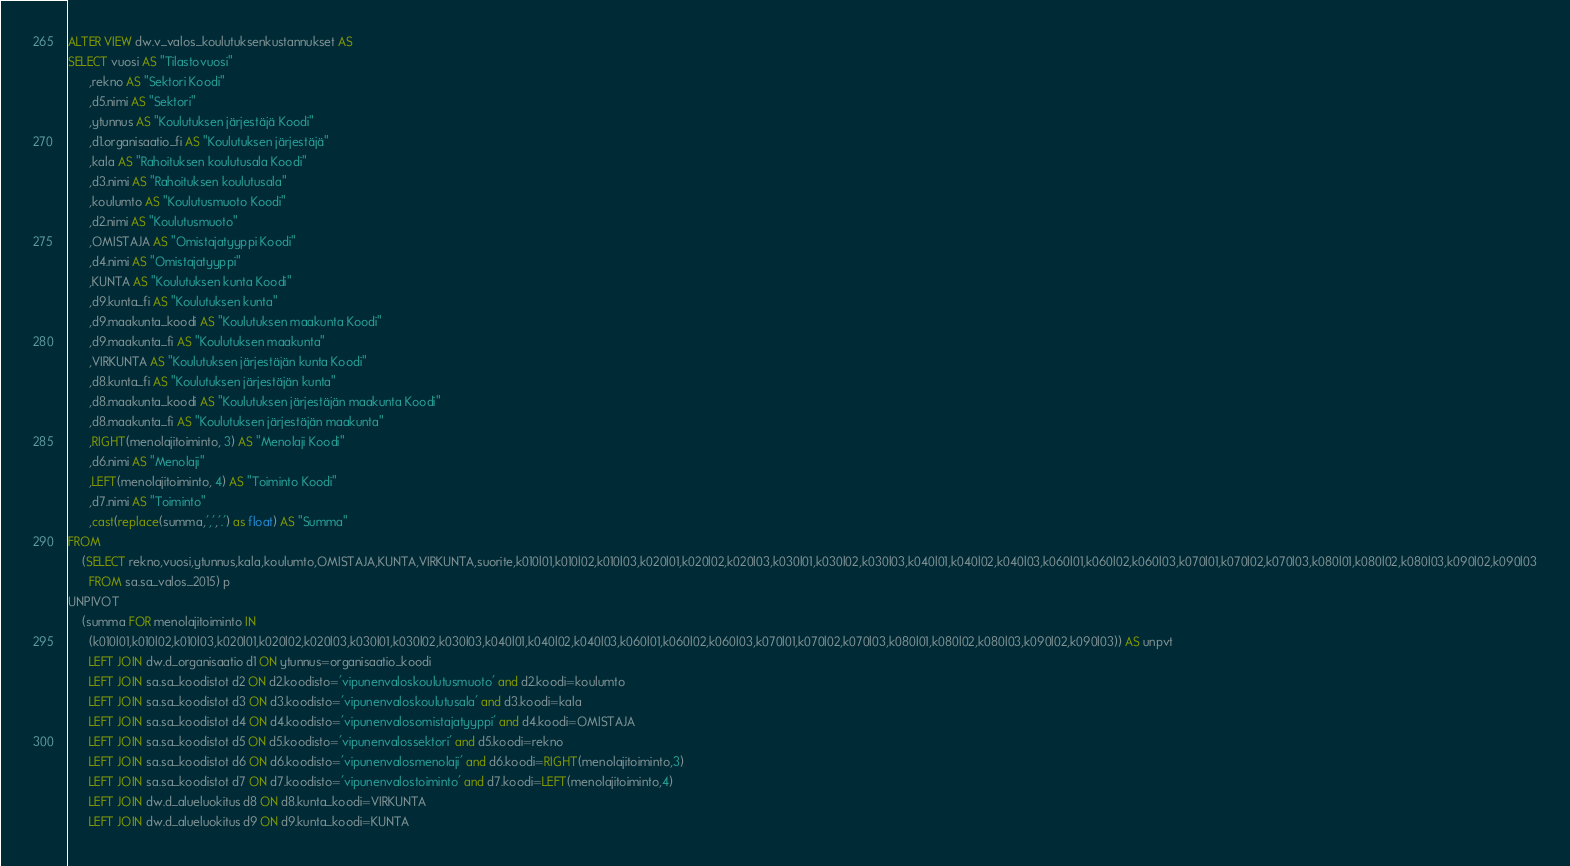Convert code to text. <code><loc_0><loc_0><loc_500><loc_500><_SQL_>ALTER VIEW dw.v_valos_koulutuksenkustannukset AS
SELECT vuosi AS "Tilastovuosi"
	  ,rekno AS "Sektori Koodi"
	  ,d5.nimi AS "Sektori"
      ,ytunnus AS "Koulutuksen järjestäjä Koodi"
	  ,d1.organisaatio_fi AS "Koulutuksen järjestäjä"
      ,kala AS "Rahoituksen koulutusala Koodi"
	  ,d3.nimi AS "Rahoituksen koulutusala"
      ,koulumto AS "Koulutusmuoto Koodi"
	  ,d2.nimi AS "Koulutusmuoto"
      ,OMISTAJA AS "Omistajatyyppi Koodi"
	  ,d4.nimi AS "Omistajatyyppi"
      ,KUNTA AS "Koulutuksen kunta Koodi"
	  ,d9.kunta_fi AS "Koulutuksen kunta"
	  ,d9.maakunta_koodi AS "Koulutuksen maakunta Koodi"
	  ,d9.maakunta_fi AS "Koulutuksen maakunta"
	  ,VIRKUNTA AS "Koulutuksen järjestäjän kunta Koodi"
	  ,d8.kunta_fi AS "Koulutuksen järjestäjän kunta"
	  ,d8.maakunta_koodi AS "Koulutuksen järjestäjän maakunta Koodi"
	  ,d8.maakunta_fi AS "Koulutuksen järjestäjän maakunta"
	  ,RIGHT(menolajitoiminto, 3) AS "Menolaji Koodi"
	  ,d6.nimi AS "Menolaji"
	  ,LEFT(menolajitoiminto, 4) AS "Toiminto Koodi"
	  ,d7.nimi AS "Toiminto"
	  ,cast(replace(summa,',','.') as float) AS "Summa"
FROM
	(SELECT rekno,vuosi,ytunnus,kala,koulumto,OMISTAJA,KUNTA,VIRKUNTA,suorite,k010l01,k010l02,k010l03,k020l01,k020l02,k020l03,k030l01,k030l02,k030l03,k040l01,k040l02,k040l03,k060l01,k060l02,k060l03,k070l01,k070l02,k070l03,k080l01,k080l02,k080l03,k090l02,k090l03
	  FROM sa.sa_valos_2015) p
UNPIVOT 
	(summa FOR menolajitoiminto IN
	  (k010l01,k010l02,k010l03,k020l01,k020l02,k020l03,k030l01,k030l02,k030l03,k040l01,k040l02,k040l03,k060l01,k060l02,k060l03,k070l01,k070l02,k070l03,k080l01,k080l02,k080l03,k090l02,k090l03)) AS unpvt
	  LEFT JOIN dw.d_organisaatio d1 ON ytunnus=organisaatio_koodi
	  LEFT JOIN sa.sa_koodistot d2 ON d2.koodisto='vipunenvaloskoulutusmuoto' and d2.koodi=koulumto
	  LEFT JOIN sa.sa_koodistot d3 ON d3.koodisto='vipunenvaloskoulutusala' and d3.koodi=kala
	  LEFT JOIN sa.sa_koodistot d4 ON d4.koodisto='vipunenvalosomistajatyyppi' and d4.koodi=OMISTAJA
	  LEFT JOIN sa.sa_koodistot d5 ON d5.koodisto='vipunenvalossektori' and d5.koodi=rekno
	  LEFT JOIN sa.sa_koodistot d6 ON d6.koodisto='vipunenvalosmenolaji' and d6.koodi=RIGHT(menolajitoiminto,3)
	  LEFT JOIN sa.sa_koodistot d7 ON d7.koodisto='vipunenvalostoiminto' and d7.koodi=LEFT(menolajitoiminto,4)
	  LEFT JOIN dw.d_alueluokitus d8 ON d8.kunta_koodi=VIRKUNTA
	  LEFT JOIN dw.d_alueluokitus d9 ON d9.kunta_koodi=KUNTA
</code> 